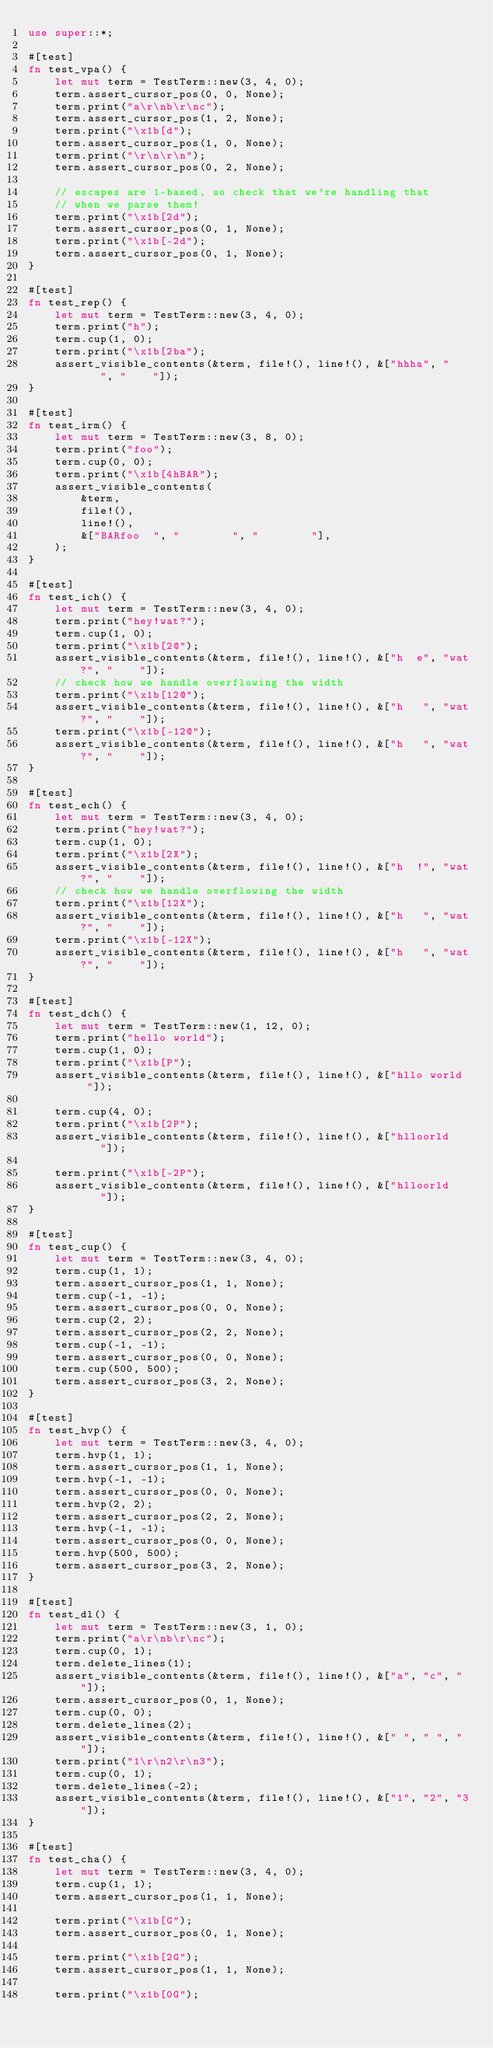Convert code to text. <code><loc_0><loc_0><loc_500><loc_500><_Rust_>use super::*;

#[test]
fn test_vpa() {
    let mut term = TestTerm::new(3, 4, 0);
    term.assert_cursor_pos(0, 0, None);
    term.print("a\r\nb\r\nc");
    term.assert_cursor_pos(1, 2, None);
    term.print("\x1b[d");
    term.assert_cursor_pos(1, 0, None);
    term.print("\r\n\r\n");
    term.assert_cursor_pos(0, 2, None);

    // escapes are 1-based, so check that we're handling that
    // when we parse them!
    term.print("\x1b[2d");
    term.assert_cursor_pos(0, 1, None);
    term.print("\x1b[-2d");
    term.assert_cursor_pos(0, 1, None);
}

#[test]
fn test_rep() {
    let mut term = TestTerm::new(3, 4, 0);
    term.print("h");
    term.cup(1, 0);
    term.print("\x1b[2ba");
    assert_visible_contents(&term, file!(), line!(), &["hhha", "    ", "    "]);
}

#[test]
fn test_irm() {
    let mut term = TestTerm::new(3, 8, 0);
    term.print("foo");
    term.cup(0, 0);
    term.print("\x1b[4hBAR");
    assert_visible_contents(
        &term,
        file!(),
        line!(),
        &["BARfoo  ", "        ", "        "],
    );
}

#[test]
fn test_ich() {
    let mut term = TestTerm::new(3, 4, 0);
    term.print("hey!wat?");
    term.cup(1, 0);
    term.print("\x1b[2@");
    assert_visible_contents(&term, file!(), line!(), &["h  e", "wat?", "    "]);
    // check how we handle overflowing the width
    term.print("\x1b[12@");
    assert_visible_contents(&term, file!(), line!(), &["h   ", "wat?", "    "]);
    term.print("\x1b[-12@");
    assert_visible_contents(&term, file!(), line!(), &["h   ", "wat?", "    "]);
}

#[test]
fn test_ech() {
    let mut term = TestTerm::new(3, 4, 0);
    term.print("hey!wat?");
    term.cup(1, 0);
    term.print("\x1b[2X");
    assert_visible_contents(&term, file!(), line!(), &["h  !", "wat?", "    "]);
    // check how we handle overflowing the width
    term.print("\x1b[12X");
    assert_visible_contents(&term, file!(), line!(), &["h   ", "wat?", "    "]);
    term.print("\x1b[-12X");
    assert_visible_contents(&term, file!(), line!(), &["h   ", "wat?", "    "]);
}

#[test]
fn test_dch() {
    let mut term = TestTerm::new(1, 12, 0);
    term.print("hello world");
    term.cup(1, 0);
    term.print("\x1b[P");
    assert_visible_contents(&term, file!(), line!(), &["hllo world  "]);

    term.cup(4, 0);
    term.print("\x1b[2P");
    assert_visible_contents(&term, file!(), line!(), &["hlloorld    "]);

    term.print("\x1b[-2P");
    assert_visible_contents(&term, file!(), line!(), &["hlloorld    "]);
}

#[test]
fn test_cup() {
    let mut term = TestTerm::new(3, 4, 0);
    term.cup(1, 1);
    term.assert_cursor_pos(1, 1, None);
    term.cup(-1, -1);
    term.assert_cursor_pos(0, 0, None);
    term.cup(2, 2);
    term.assert_cursor_pos(2, 2, None);
    term.cup(-1, -1);
    term.assert_cursor_pos(0, 0, None);
    term.cup(500, 500);
    term.assert_cursor_pos(3, 2, None);
}

#[test]
fn test_hvp() {
    let mut term = TestTerm::new(3, 4, 0);
    term.hvp(1, 1);
    term.assert_cursor_pos(1, 1, None);
    term.hvp(-1, -1);
    term.assert_cursor_pos(0, 0, None);
    term.hvp(2, 2);
    term.assert_cursor_pos(2, 2, None);
    term.hvp(-1, -1);
    term.assert_cursor_pos(0, 0, None);
    term.hvp(500, 500);
    term.assert_cursor_pos(3, 2, None);
}

#[test]
fn test_dl() {
    let mut term = TestTerm::new(3, 1, 0);
    term.print("a\r\nb\r\nc");
    term.cup(0, 1);
    term.delete_lines(1);
    assert_visible_contents(&term, file!(), line!(), &["a", "c", " "]);
    term.assert_cursor_pos(0, 1, None);
    term.cup(0, 0);
    term.delete_lines(2);
    assert_visible_contents(&term, file!(), line!(), &[" ", " ", " "]);
    term.print("1\r\n2\r\n3");
    term.cup(0, 1);
    term.delete_lines(-2);
    assert_visible_contents(&term, file!(), line!(), &["1", "2", "3"]);
}

#[test]
fn test_cha() {
    let mut term = TestTerm::new(3, 4, 0);
    term.cup(1, 1);
    term.assert_cursor_pos(1, 1, None);

    term.print("\x1b[G");
    term.assert_cursor_pos(0, 1, None);

    term.print("\x1b[2G");
    term.assert_cursor_pos(1, 1, None);

    term.print("\x1b[0G");</code> 